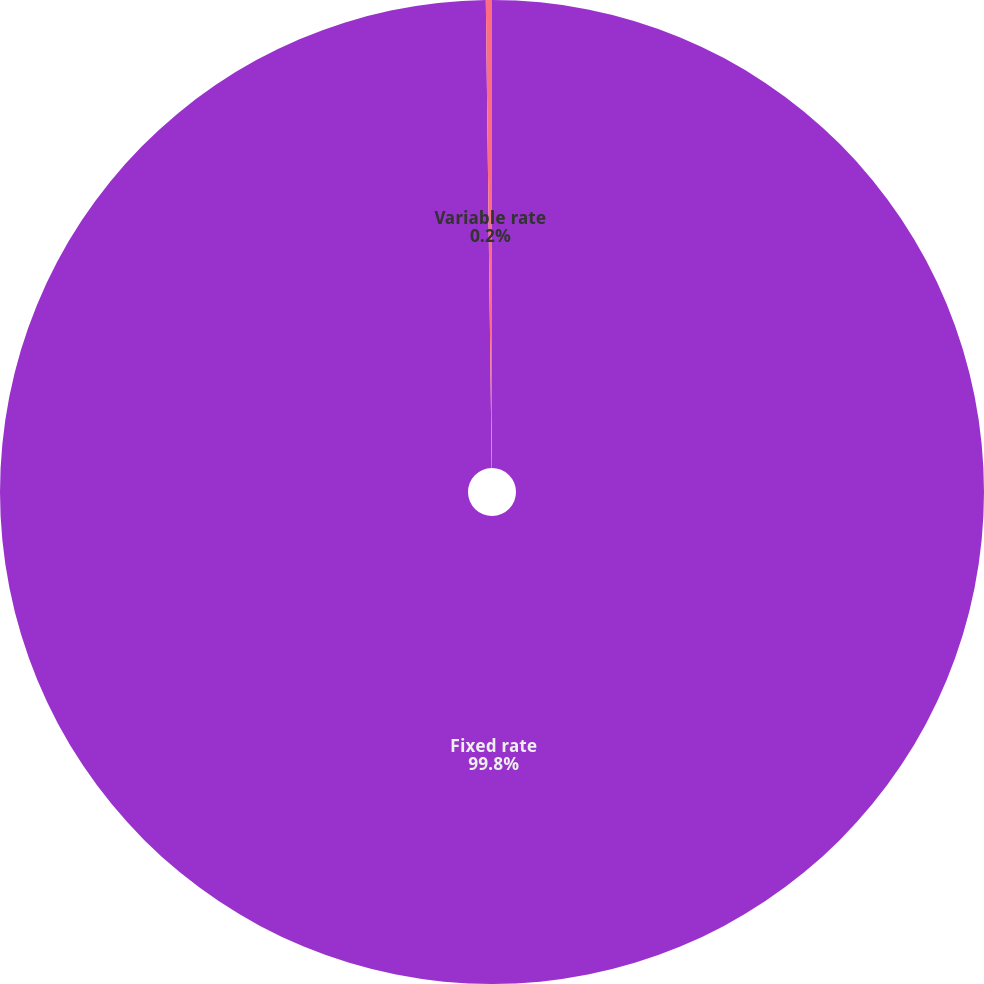Convert chart to OTSL. <chart><loc_0><loc_0><loc_500><loc_500><pie_chart><fcel>Fixed rate<fcel>Variable rate<nl><fcel>99.8%<fcel>0.2%<nl></chart> 